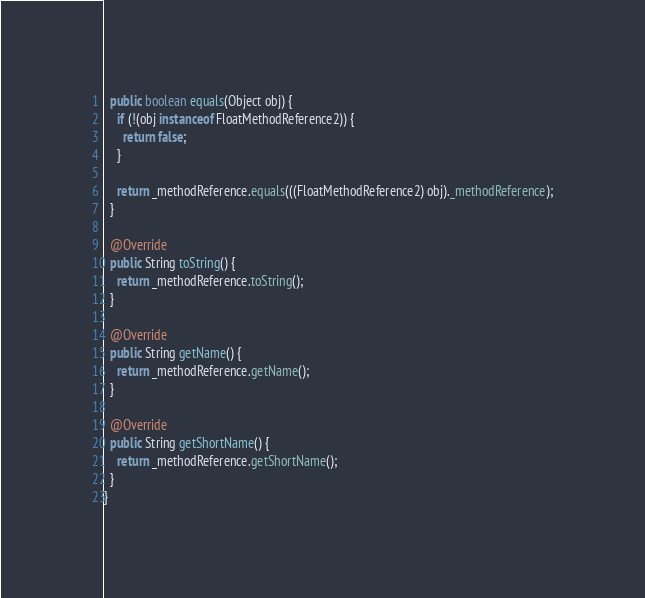<code> <loc_0><loc_0><loc_500><loc_500><_Java_>  public boolean equals(Object obj) {
    if (!(obj instanceof FloatMethodReference2)) {
      return false;
    }

    return _methodReference.equals(((FloatMethodReference2) obj)._methodReference);
  }

  @Override
  public String toString() {
    return _methodReference.toString();
  }

  @Override
  public String getName() {
    return _methodReference.getName();
  }

  @Override
  public String getShortName() {
    return _methodReference.getShortName();
  }
}
</code> 